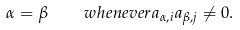Convert formula to latex. <formula><loc_0><loc_0><loc_500><loc_500>\alpha = \beta \quad w h e n e v e r a _ { \alpha , i } a _ { \beta , j } \not = 0 .</formula> 